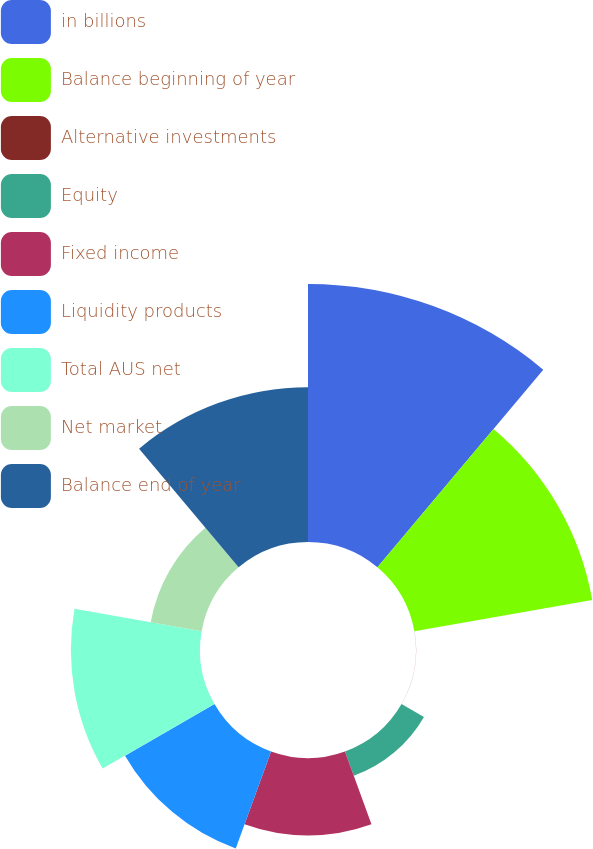Convert chart. <chart><loc_0><loc_0><loc_500><loc_500><pie_chart><fcel>in billions<fcel>Balance beginning of year<fcel>Alternative investments<fcel>Equity<fcel>Fixed income<fcel>Liquidity products<fcel>Total AUS net<fcel>Net market<fcel>Balance end of year<nl><fcel>26.3%<fcel>18.41%<fcel>0.01%<fcel>2.64%<fcel>7.9%<fcel>10.53%<fcel>13.16%<fcel>5.27%<fcel>15.78%<nl></chart> 